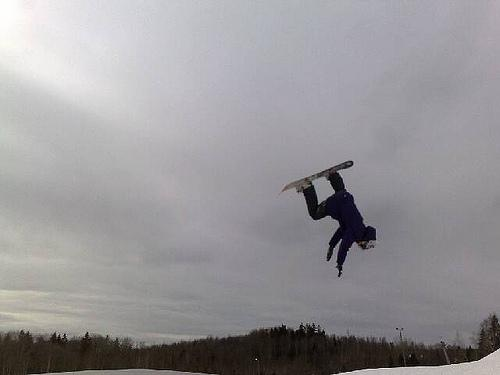Question: how is the person facing in the picture?
Choices:
A. Left.
B. Towards the ground.
C. Right.
D. Up.
Answer with the letter. Answer: B Question: what is the person riding?
Choices:
A. Skiis.
B. A snowboard.
C. A ski lift.
D. A snowmobile.
Answer with the letter. Answer: B Question: when is this picture taken?
Choices:
A. At a ski mountain.
B. During a person performing a snowboarding jump.
C. Daytime.
D. During a competition.
Answer with the letter. Answer: B Question: why is the ground white?
Choices:
A. It snowed yesterday.
B. Covered by snow.
C. The picture is taken at a ski resort.
D. It's winter.
Answer with the letter. Answer: B 